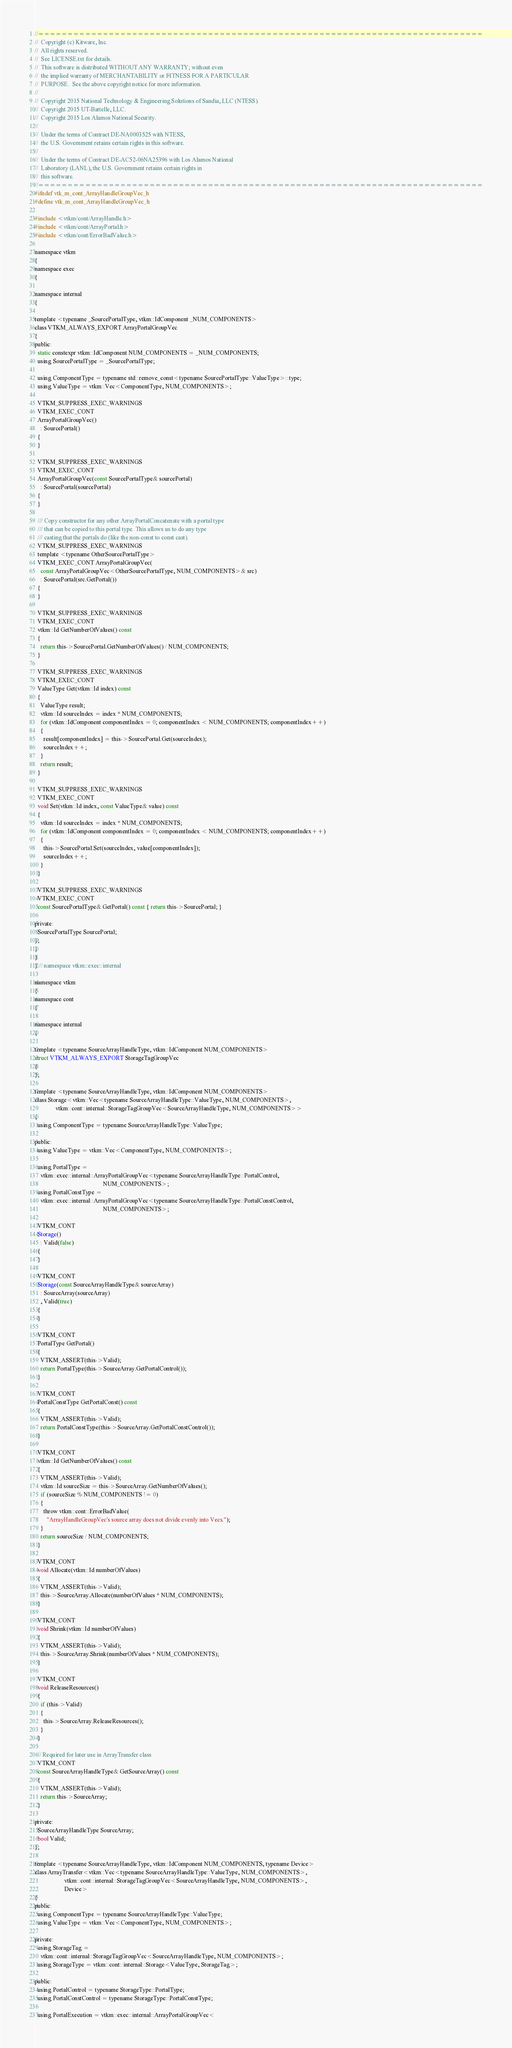Convert code to text. <code><loc_0><loc_0><loc_500><loc_500><_C_>//============================================================================
//  Copyright (c) Kitware, Inc.
//  All rights reserved.
//  See LICENSE.txt for details.
//  This software is distributed WITHOUT ANY WARRANTY; without even
//  the implied warranty of MERCHANTABILITY or FITNESS FOR A PARTICULAR
//  PURPOSE.  See the above copyright notice for more information.
//
//  Copyright 2015 National Technology & Engineering Solutions of Sandia, LLC (NTESS).
//  Copyright 2015 UT-Battelle, LLC.
//  Copyright 2015 Los Alamos National Security.
//
//  Under the terms of Contract DE-NA0003525 with NTESS,
//  the U.S. Government retains certain rights in this software.
//
//  Under the terms of Contract DE-AC52-06NA25396 with Los Alamos National
//  Laboratory (LANL), the U.S. Government retains certain rights in
//  this software.
//============================================================================
#ifndef vtk_m_cont_ArrayHandleGroupVec_h
#define vtk_m_cont_ArrayHandleGroupVec_h

#include <vtkm/cont/ArrayHandle.h>
#include <vtkm/cont/ArrayPortal.h>
#include <vtkm/cont/ErrorBadValue.h>

namespace vtkm
{
namespace exec
{

namespace internal
{

template <typename _SourcePortalType, vtkm::IdComponent _NUM_COMPONENTS>
class VTKM_ALWAYS_EXPORT ArrayPortalGroupVec
{
public:
  static constexpr vtkm::IdComponent NUM_COMPONENTS = _NUM_COMPONENTS;
  using SourcePortalType = _SourcePortalType;

  using ComponentType = typename std::remove_const<typename SourcePortalType::ValueType>::type;
  using ValueType = vtkm::Vec<ComponentType, NUM_COMPONENTS>;

  VTKM_SUPPRESS_EXEC_WARNINGS
  VTKM_EXEC_CONT
  ArrayPortalGroupVec()
    : SourcePortal()
  {
  }

  VTKM_SUPPRESS_EXEC_WARNINGS
  VTKM_EXEC_CONT
  ArrayPortalGroupVec(const SourcePortalType& sourcePortal)
    : SourcePortal(sourcePortal)
  {
  }

  /// Copy constructor for any other ArrayPortalConcatenate with a portal type
  /// that can be copied to this portal type. This allows us to do any type
  /// casting that the portals do (like the non-const to const cast).
  VTKM_SUPPRESS_EXEC_WARNINGS
  template <typename OtherSourcePortalType>
  VTKM_EXEC_CONT ArrayPortalGroupVec(
    const ArrayPortalGroupVec<OtherSourcePortalType, NUM_COMPONENTS>& src)
    : SourcePortal(src.GetPortal())
  {
  }

  VTKM_SUPPRESS_EXEC_WARNINGS
  VTKM_EXEC_CONT
  vtkm::Id GetNumberOfValues() const
  {
    return this->SourcePortal.GetNumberOfValues() / NUM_COMPONENTS;
  }

  VTKM_SUPPRESS_EXEC_WARNINGS
  VTKM_EXEC_CONT
  ValueType Get(vtkm::Id index) const
  {
    ValueType result;
    vtkm::Id sourceIndex = index * NUM_COMPONENTS;
    for (vtkm::IdComponent componentIndex = 0; componentIndex < NUM_COMPONENTS; componentIndex++)
    {
      result[componentIndex] = this->SourcePortal.Get(sourceIndex);
      sourceIndex++;
    }
    return result;
  }

  VTKM_SUPPRESS_EXEC_WARNINGS
  VTKM_EXEC_CONT
  void Set(vtkm::Id index, const ValueType& value) const
  {
    vtkm::Id sourceIndex = index * NUM_COMPONENTS;
    for (vtkm::IdComponent componentIndex = 0; componentIndex < NUM_COMPONENTS; componentIndex++)
    {
      this->SourcePortal.Set(sourceIndex, value[componentIndex]);
      sourceIndex++;
    }
  }

  VTKM_SUPPRESS_EXEC_WARNINGS
  VTKM_EXEC_CONT
  const SourcePortalType& GetPortal() const { return this->SourcePortal; }

private:
  SourcePortalType SourcePortal;
};
}
}
} // namespace vtkm::exec::internal

namespace vtkm
{
namespace cont
{

namespace internal
{

template <typename SourceArrayHandleType, vtkm::IdComponent NUM_COMPONENTS>
struct VTKM_ALWAYS_EXPORT StorageTagGroupVec
{
};

template <typename SourceArrayHandleType, vtkm::IdComponent NUM_COMPONENTS>
class Storage<vtkm::Vec<typename SourceArrayHandleType::ValueType, NUM_COMPONENTS>,
              vtkm::cont::internal::StorageTagGroupVec<SourceArrayHandleType, NUM_COMPONENTS>>
{
  using ComponentType = typename SourceArrayHandleType::ValueType;

public:
  using ValueType = vtkm::Vec<ComponentType, NUM_COMPONENTS>;

  using PortalType =
    vtkm::exec::internal::ArrayPortalGroupVec<typename SourceArrayHandleType::PortalControl,
                                              NUM_COMPONENTS>;
  using PortalConstType =
    vtkm::exec::internal::ArrayPortalGroupVec<typename SourceArrayHandleType::PortalConstControl,
                                              NUM_COMPONENTS>;

  VTKM_CONT
  Storage()
    : Valid(false)
  {
  }

  VTKM_CONT
  Storage(const SourceArrayHandleType& sourceArray)
    : SourceArray(sourceArray)
    , Valid(true)
  {
  }

  VTKM_CONT
  PortalType GetPortal()
  {
    VTKM_ASSERT(this->Valid);
    return PortalType(this->SourceArray.GetPortalControl());
  }

  VTKM_CONT
  PortalConstType GetPortalConst() const
  {
    VTKM_ASSERT(this->Valid);
    return PortalConstType(this->SourceArray.GetPortalConstControl());
  }

  VTKM_CONT
  vtkm::Id GetNumberOfValues() const
  {
    VTKM_ASSERT(this->Valid);
    vtkm::Id sourceSize = this->SourceArray.GetNumberOfValues();
    if (sourceSize % NUM_COMPONENTS != 0)
    {
      throw vtkm::cont::ErrorBadValue(
        "ArrayHandleGroupVec's source array does not divide evenly into Vecs.");
    }
    return sourceSize / NUM_COMPONENTS;
  }

  VTKM_CONT
  void Allocate(vtkm::Id numberOfValues)
  {
    VTKM_ASSERT(this->Valid);
    this->SourceArray.Allocate(numberOfValues * NUM_COMPONENTS);
  }

  VTKM_CONT
  void Shrink(vtkm::Id numberOfValues)
  {
    VTKM_ASSERT(this->Valid);
    this->SourceArray.Shrink(numberOfValues * NUM_COMPONENTS);
  }

  VTKM_CONT
  void ReleaseResources()
  {
    if (this->Valid)
    {
      this->SourceArray.ReleaseResources();
    }
  }

  // Required for later use in ArrayTransfer class
  VTKM_CONT
  const SourceArrayHandleType& GetSourceArray() const
  {
    VTKM_ASSERT(this->Valid);
    return this->SourceArray;
  }

private:
  SourceArrayHandleType SourceArray;
  bool Valid;
};

template <typename SourceArrayHandleType, vtkm::IdComponent NUM_COMPONENTS, typename Device>
class ArrayTransfer<vtkm::Vec<typename SourceArrayHandleType::ValueType, NUM_COMPONENTS>,
                    vtkm::cont::internal::StorageTagGroupVec<SourceArrayHandleType, NUM_COMPONENTS>,
                    Device>
{
public:
  using ComponentType = typename SourceArrayHandleType::ValueType;
  using ValueType = vtkm::Vec<ComponentType, NUM_COMPONENTS>;

private:
  using StorageTag =
    vtkm::cont::internal::StorageTagGroupVec<SourceArrayHandleType, NUM_COMPONENTS>;
  using StorageType = vtkm::cont::internal::Storage<ValueType, StorageTag>;

public:
  using PortalControl = typename StorageType::PortalType;
  using PortalConstControl = typename StorageType::PortalConstType;

  using PortalExecution = vtkm::exec::internal::ArrayPortalGroupVec<</code> 